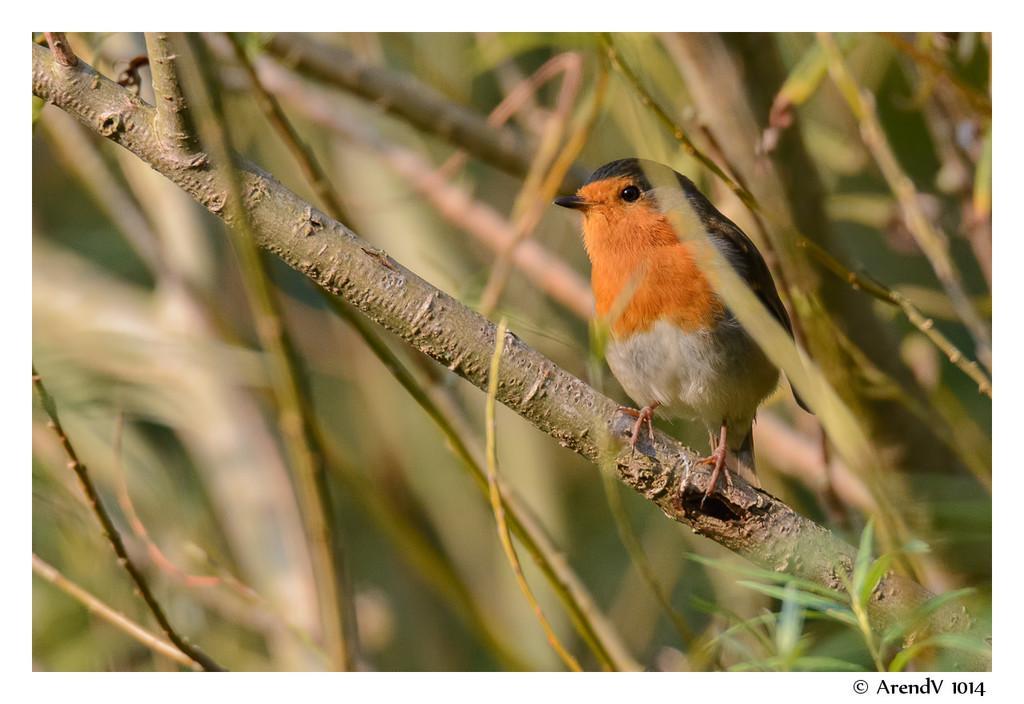Can you describe this image briefly? In the foreground of this image, there is a bird on the branch. In the background, there are branches of plants. 